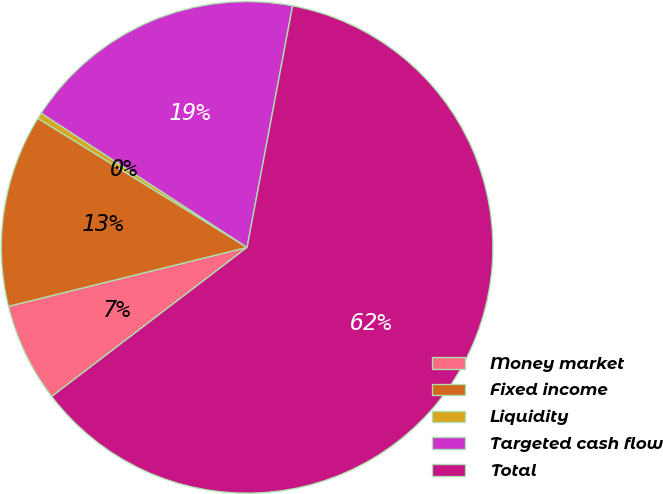Convert chart. <chart><loc_0><loc_0><loc_500><loc_500><pie_chart><fcel>Money market<fcel>Fixed income<fcel>Liquidity<fcel>Targeted cash flow<fcel>Total<nl><fcel>6.52%<fcel>12.65%<fcel>0.4%<fcel>18.77%<fcel>61.66%<nl></chart> 